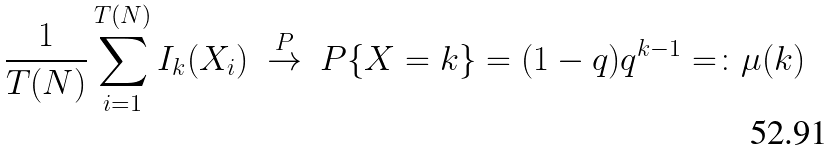<formula> <loc_0><loc_0><loc_500><loc_500>\frac { 1 } { T ( N ) } \sum _ { i = 1 } ^ { T ( N ) } I _ { k } ( X _ { i } ) \ \stackrel { P } { \rightarrow } \ { P } \{ X = k \} = ( 1 - q ) q ^ { k - 1 } = \colon \mu ( k )</formula> 